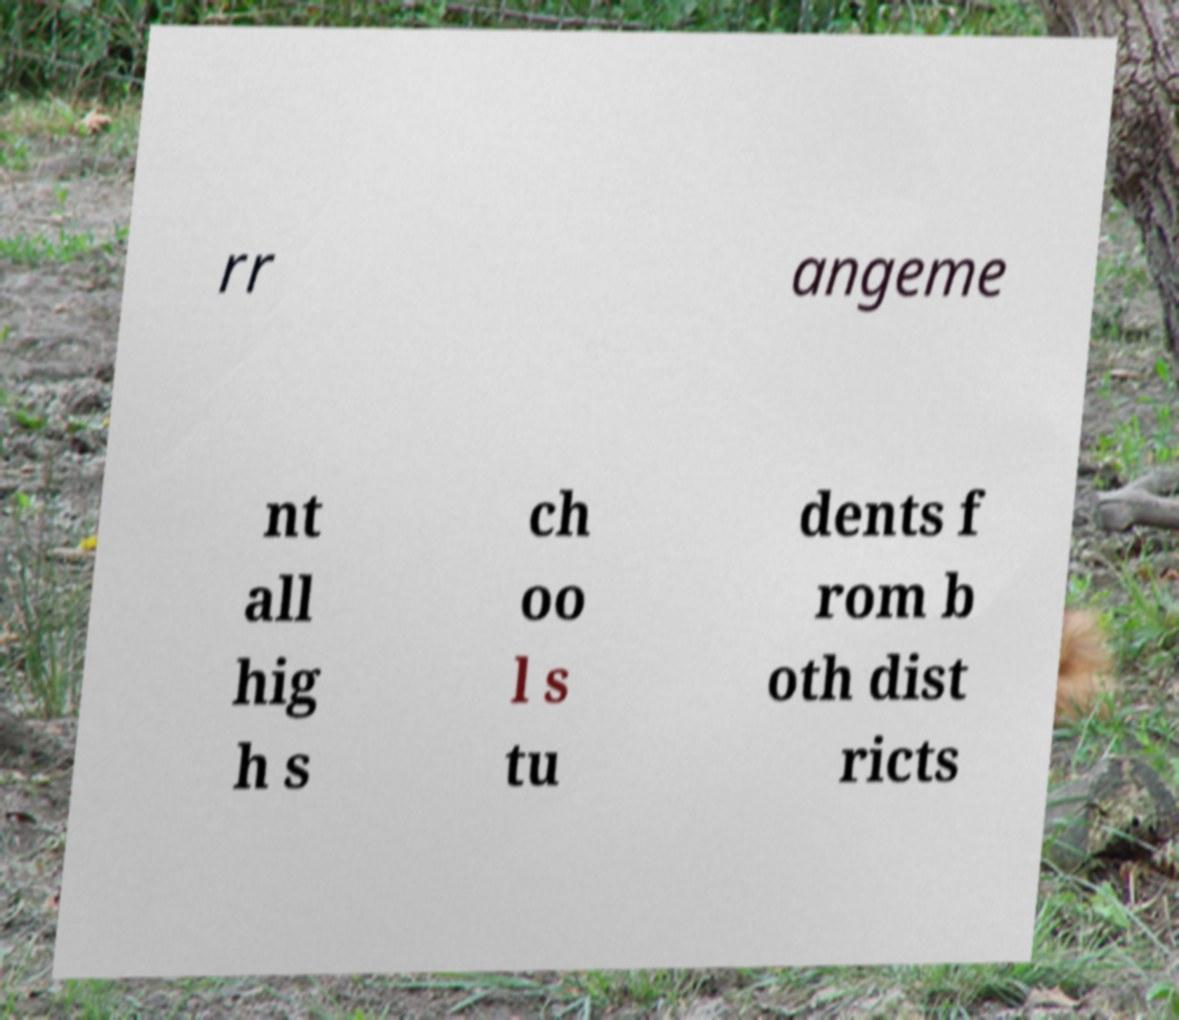I need the written content from this picture converted into text. Can you do that? rr angeme nt all hig h s ch oo l s tu dents f rom b oth dist ricts 